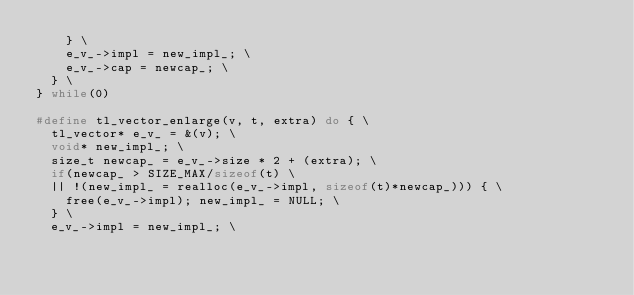Convert code to text. <code><loc_0><loc_0><loc_500><loc_500><_C_>		} \
		e_v_->impl = new_impl_; \
		e_v_->cap = newcap_; \
	} \
} while(0)

#define tl_vector_enlarge(v, t, extra) do { \
	tl_vector* e_v_ = &(v); \
	void* new_impl_; \
	size_t newcap_ = e_v_->size * 2 + (extra); \
	if(newcap_ > SIZE_MAX/sizeof(t) \
	|| !(new_impl_ = realloc(e_v_->impl, sizeof(t)*newcap_))) { \
		free(e_v_->impl); new_impl_ = NULL; \
	} \
	e_v_->impl = new_impl_; \</code> 